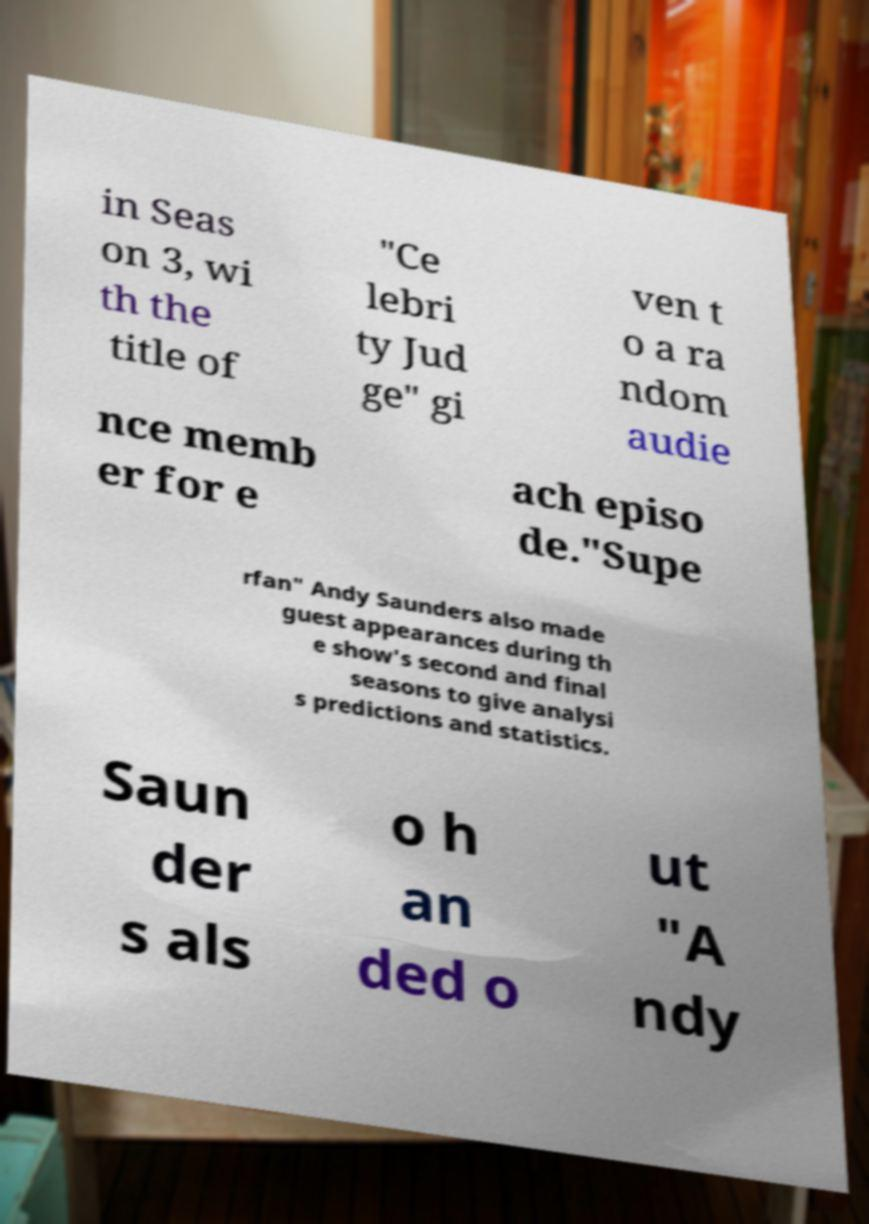Could you assist in decoding the text presented in this image and type it out clearly? in Seas on 3, wi th the title of "Ce lebri ty Jud ge" gi ven t o a ra ndom audie nce memb er for e ach episo de."Supe rfan" Andy Saunders also made guest appearances during th e show's second and final seasons to give analysi s predictions and statistics. Saun der s als o h an ded o ut "A ndy 